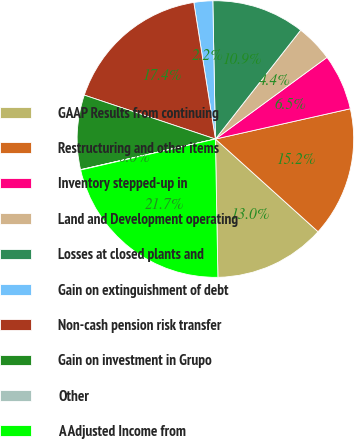Convert chart to OTSL. <chart><loc_0><loc_0><loc_500><loc_500><pie_chart><fcel>GAAP Results from continuing<fcel>Restructuring and other items<fcel>Inventory stepped-up in<fcel>Land and Development operating<fcel>Losses at closed plants and<fcel>Gain on extinguishment of debt<fcel>Non-cash pension risk transfer<fcel>Gain on investment in Grupo<fcel>Other<fcel>A Adjusted Income from<nl><fcel>13.03%<fcel>15.2%<fcel>6.54%<fcel>4.37%<fcel>10.87%<fcel>2.2%<fcel>17.36%<fcel>8.7%<fcel>0.04%<fcel>21.69%<nl></chart> 